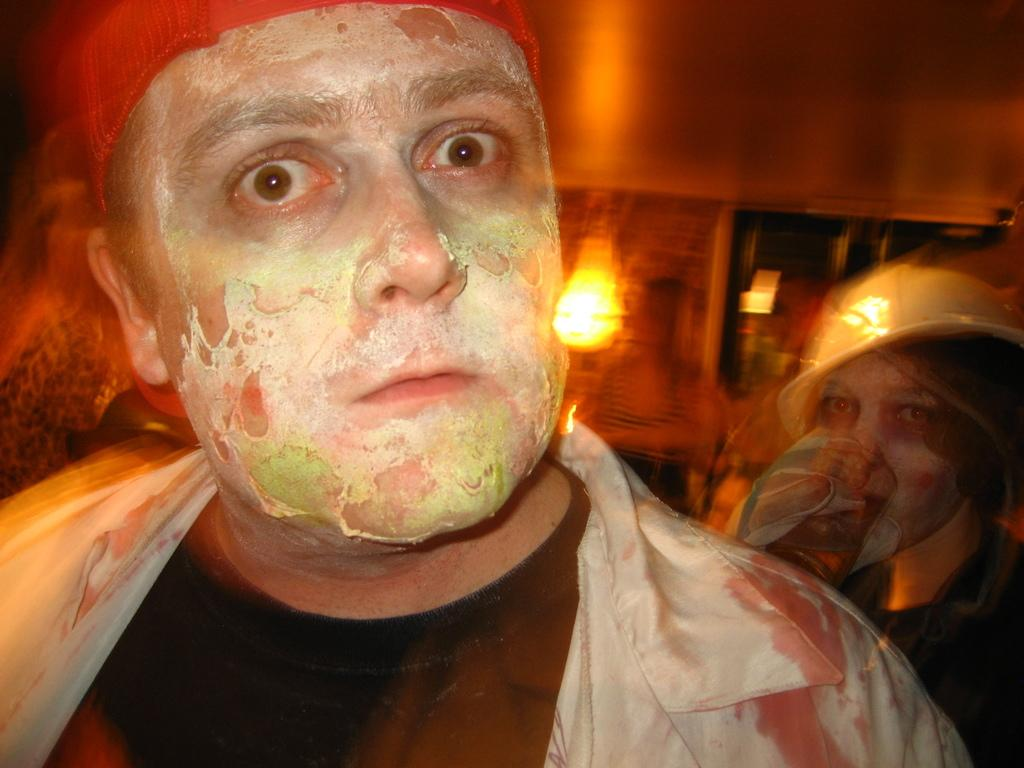Who or what is present in the image? There are people in the image. What can be inferred about the people based on their appearance? The people appear to be dressed for Halloween. What can be seen in the background of the image? There is a lamp attached to the wall in the background of the image. What type of body is visible in the image? There is no body present in the image; it features people dressed for Halloween. What is the limit of the vase in the image? There is no vase present in the image, so it is not possible to determine its limit. 